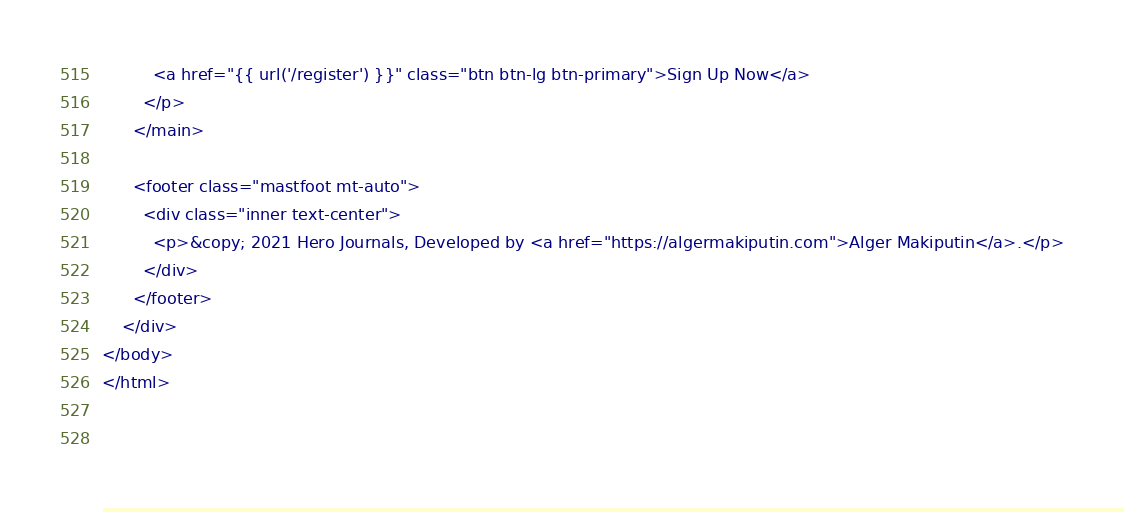Convert code to text. <code><loc_0><loc_0><loc_500><loc_500><_PHP_>          <a href="{{ url('/register') }}" class="btn btn-lg btn-primary">Sign Up Now</a>
        </p>
      </main>

      <footer class="mastfoot mt-auto">
        <div class="inner text-center">
          <p>&copy; 2021 Hero Journals, Developed by <a href="https://algermakiputin.com">Alger Makiputin</a>.</p>
        </div>
      </footer>
    </div>
</body>
</html>

 </code> 